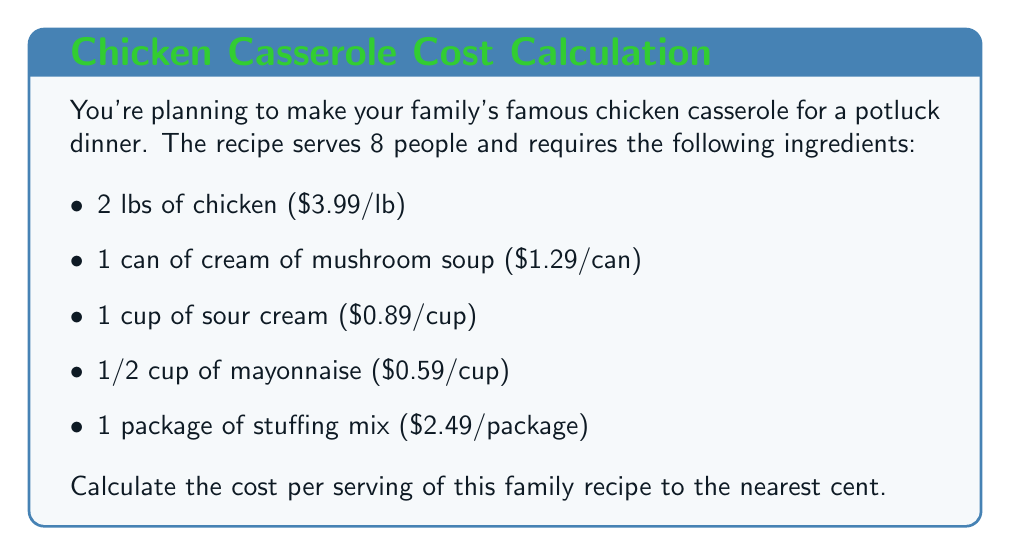Show me your answer to this math problem. Let's break this down step-by-step:

1. Calculate the cost of each ingredient:
   - Chicken: $2 \times \$3.99 = \$7.98$
   - Cream of mushroom soup: $\$1.29$
   - Sour cream: $\$0.89$
   - Mayonnaise: $\frac{1}{2} \times \$0.59 = \$0.295$
   - Stuffing mix: $\$2.49$

2. Sum up the total cost of all ingredients:
   $$\$7.98 + \$1.29 + \$0.89 + \$0.295 + \$2.49 = \$12.945$$

3. Calculate the cost per serving by dividing the total cost by the number of servings:
   $$\text{Cost per serving} = \frac{\text{Total cost}}{\text{Number of servings}} = \frac{\$12.945}{8}$$

4. Evaluate the fraction:
   $$\frac{\$12.945}{8} = \$1.618125$$

5. Round to the nearest cent:
   $\$1.62$ per serving
Answer: $\$1.62$ per serving 